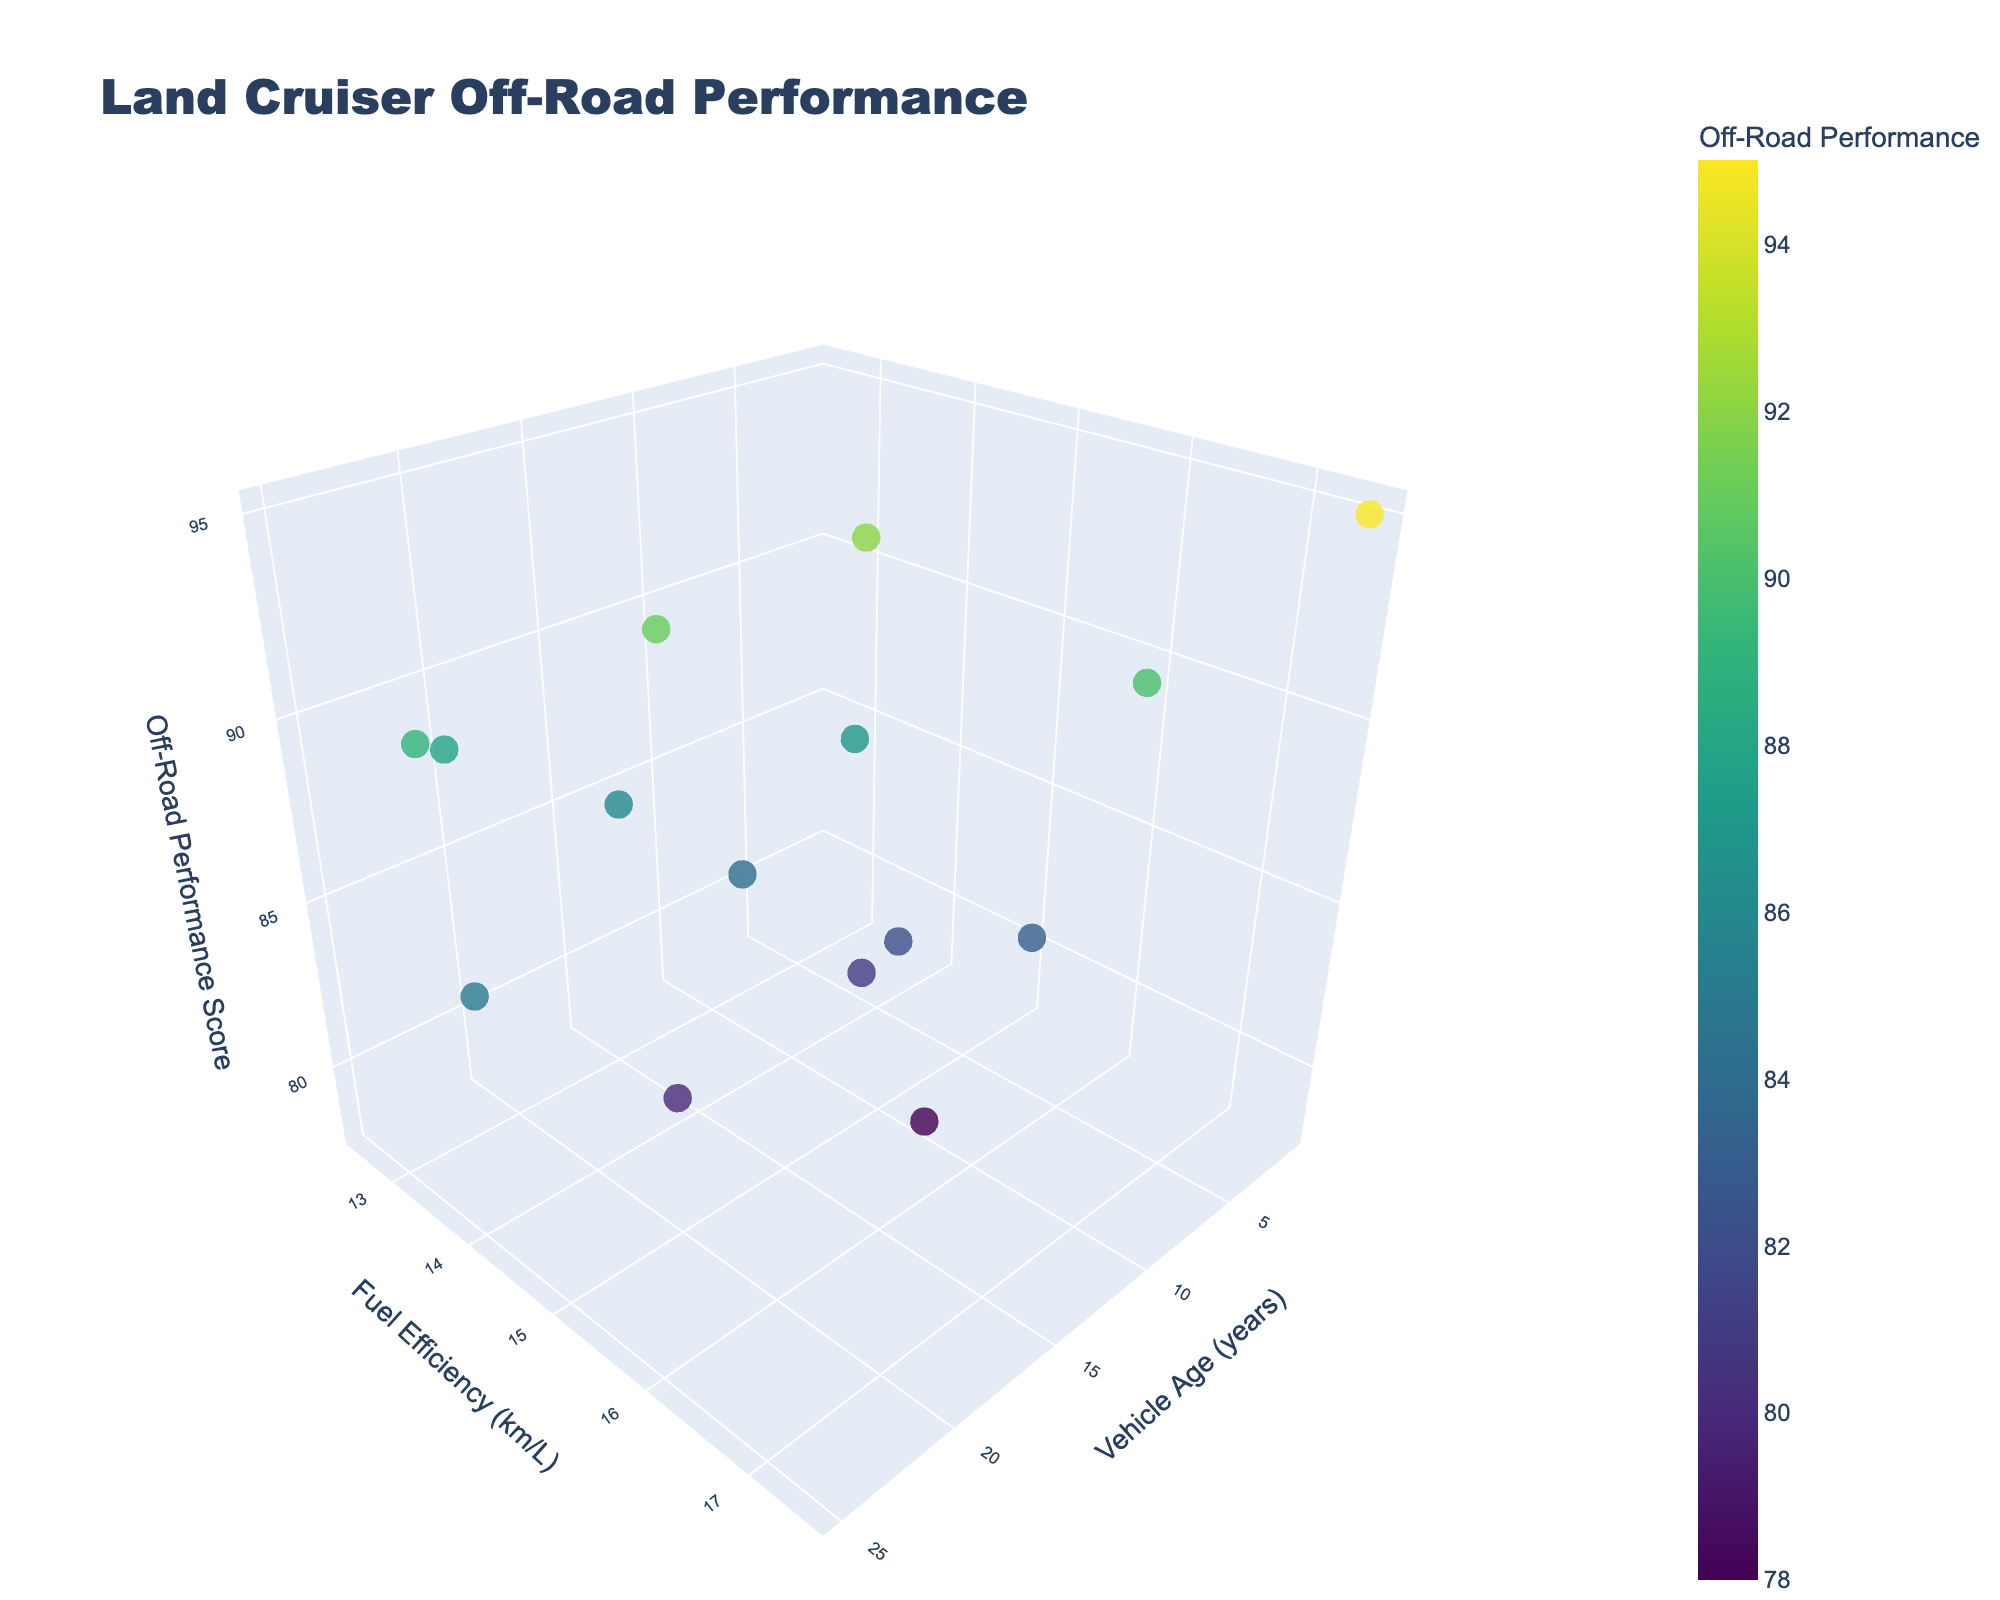What's the terrain type for the Land Cruiser with the best off-road performance? The point with the highest off-road performance score should be identified by examining the color gradient and the z-axis values. The best off-road performance is represented by the highest z-axis value. Checking the associated model and terrain type hover text indicates it is the LC300 with a tundra terrain.
Answer: Tundra How does fuel efficiency compare between the Land Cruiser Prado and the FJ Cruiser? By observing the fuel efficiency values (y-axis) for both models in the 3D scatter plot, we find that the fuel efficiency for the Land Cruiser Prado is 15.5 km/L, while the FJ Cruiser has 14.8 km/L. Prado has slightly better fuel efficiency compared to the FJ Cruiser.
Answer: Prado has higher fuel efficiency Which model is the newest and how does its off-road performance compare? To identify the newest model, find the point with the lowest vehicle age on the x-axis. The LC300 has a vehicle age of 1 year. Comparing its z-axis value for off-road performance shows that it has very high off-road performance.
Answer: LC300, high off-road performance Which Land Cruiser model has the lowest fuel efficiency and what is that value? Identify the point with the lowest y-axis value (fuel efficiency). The Land Cruiser 80 Series is identified with a fuel efficiency of 12.5 km/L.
Answer: Land Cruiser 80 Series, 12.5 km/L Are newer vehicle models generally more fuel-efficient than older models? By observing the distribution of points along the x-axis (vehicle age) and y-axis (fuel efficiency), there is a visible trend that newer models (points closer to the left) generally appear higher on the y-axis (more fuel-efficient). However, exceptions and variations can occur.
Answer: Generally, yes Which two models have the closest off-road performance but significantly different vehicle ages? Identify two points with similar z-axis values (off-road performance scores) but different x-axis values (vehicle ages). The Land Cruiser 70 Series (25 years) and Land Cruiser 76 Series (18 years) both have relatively close off-road performance scores around 85 and 80, respectively.
Answer: 70 Series and 76 Series What is the average fuel efficiency of the Land Cruiser models aged 10 years and over? Filter the points with vehicle age >= 10 years. Models: 70 Series (14.2), 80 Series (12.5), 100 Series (13.2), 76 Series (14.5), GXL (13.9), Troop Carrier (12.8), VDJ78 (13.5). Summing their fuel efficiencies: (14.2 + 12.5 + 13.2 + 14.5 + 13.9 + 12.8 + 13.5) = 94.6. The number of models is 7, so the average is 94.6 / 7 = ~13.5 km/L.
Answer: ~13.5 km/L Which terrain type is associated with the Land Cruiser model that has the highest fuel efficiency? Find the point with the highest y-axis value (fuel efficiency). The Land Cruiser LC300 has the highest fuel efficiency (17.5 km/L) and is associated with tundra terrain.
Answer: Tundra Which model has the greatest spread between its fuel efficiency and off-road performance? To determine the spread, calculate the difference between the y-axis (fuel efficiency) and z-axis (off-road performance) for each model. The LC300 with 17.5 km/L fuel efficiency and 95 off-road performance has a spread of 77.5, which is the largest among all models.
Answer: LC300 How many models fall within the off-road performance score range of 80 to 90? Count the data points that have z-axis values between 80 and 90. The models are: Land Cruiser Prado (78), FJ Cruiser (82), Land Cruiser 100 Series (86), Land Cruiser 76 Series (80), Land Cruiser 79 Series (87), Land Cruiser GXL (84), Land Cruiser GX (81), Land Cruiser Sahara (83), totaling 7 models.
Answer: 7 